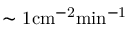<formula> <loc_0><loc_0><loc_500><loc_500>\sim { 1 c m ^ { - 2 } \min ^ { - 1 } }</formula> 